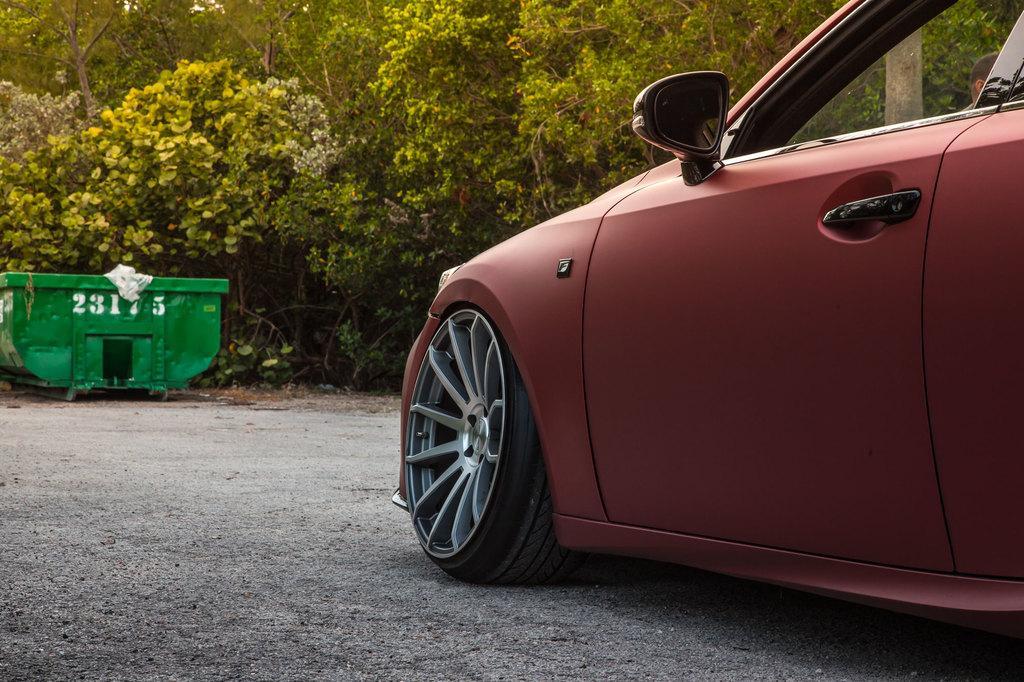Describe this image in one or two sentences. This is the picture of a road. In this image there is a car on the road. At the back there is an object and there are trees. At the bottom there is a road. 